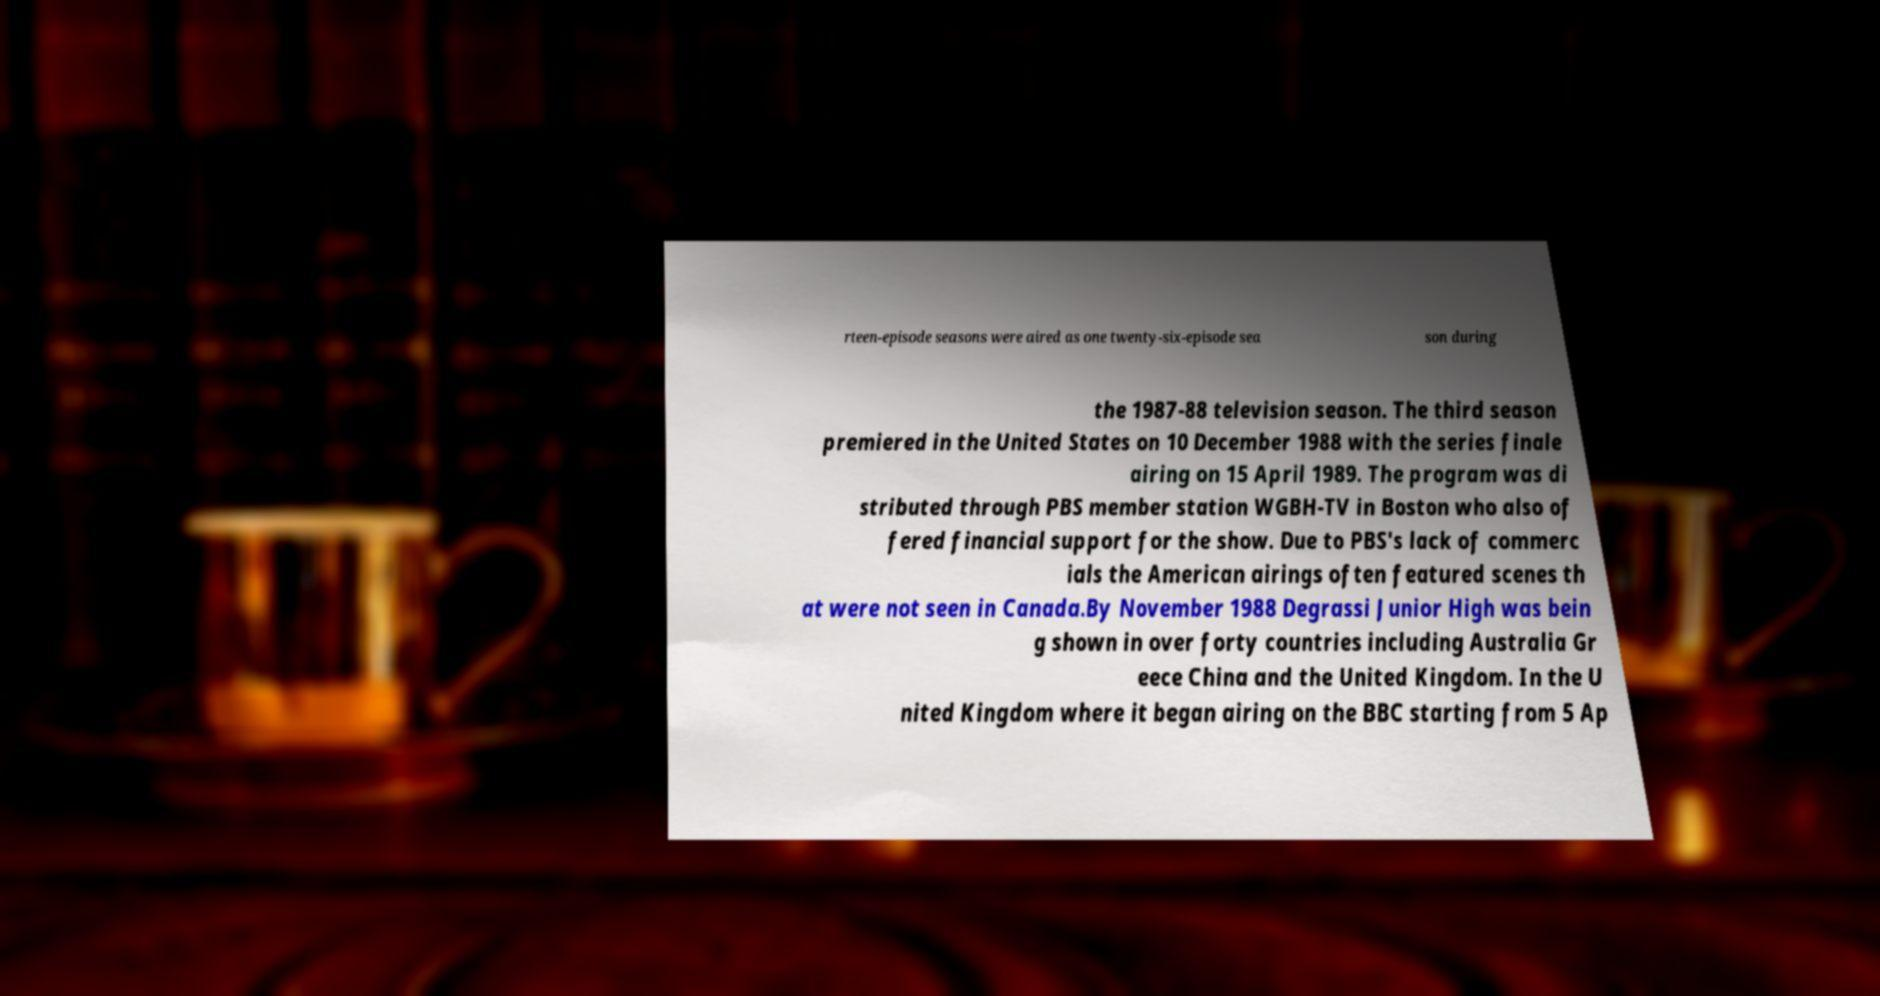Can you accurately transcribe the text from the provided image for me? rteen-episode seasons were aired as one twenty-six-episode sea son during the 1987-88 television season. The third season premiered in the United States on 10 December 1988 with the series finale airing on 15 April 1989. The program was di stributed through PBS member station WGBH-TV in Boston who also of fered financial support for the show. Due to PBS's lack of commerc ials the American airings often featured scenes th at were not seen in Canada.By November 1988 Degrassi Junior High was bein g shown in over forty countries including Australia Gr eece China and the United Kingdom. In the U nited Kingdom where it began airing on the BBC starting from 5 Ap 